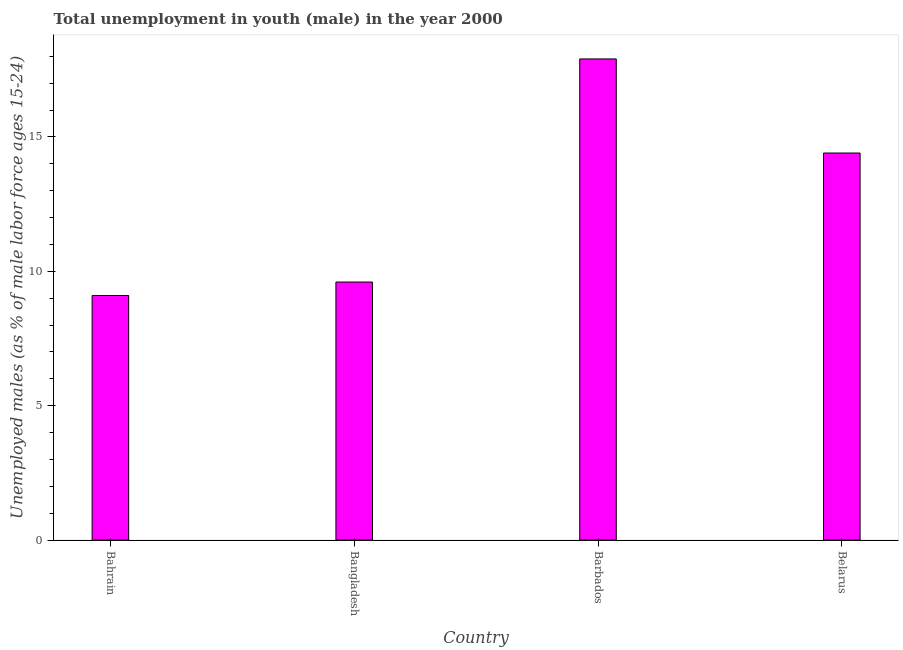What is the title of the graph?
Ensure brevity in your answer.  Total unemployment in youth (male) in the year 2000. What is the label or title of the X-axis?
Offer a terse response. Country. What is the label or title of the Y-axis?
Give a very brief answer. Unemployed males (as % of male labor force ages 15-24). What is the unemployed male youth population in Belarus?
Your answer should be very brief. 14.4. Across all countries, what is the maximum unemployed male youth population?
Provide a short and direct response. 17.9. Across all countries, what is the minimum unemployed male youth population?
Ensure brevity in your answer.  9.1. In which country was the unemployed male youth population maximum?
Make the answer very short. Barbados. In which country was the unemployed male youth population minimum?
Your answer should be compact. Bahrain. What is the sum of the unemployed male youth population?
Provide a succinct answer. 51. What is the average unemployed male youth population per country?
Your answer should be compact. 12.75. What is the median unemployed male youth population?
Make the answer very short. 12. In how many countries, is the unemployed male youth population greater than 9 %?
Provide a succinct answer. 4. What is the ratio of the unemployed male youth population in Bangladesh to that in Barbados?
Give a very brief answer. 0.54. What is the difference between the highest and the second highest unemployed male youth population?
Provide a short and direct response. 3.5. What is the difference between the highest and the lowest unemployed male youth population?
Your answer should be compact. 8.8. Are all the bars in the graph horizontal?
Your response must be concise. No. Are the values on the major ticks of Y-axis written in scientific E-notation?
Your response must be concise. No. What is the Unemployed males (as % of male labor force ages 15-24) of Bahrain?
Provide a succinct answer. 9.1. What is the Unemployed males (as % of male labor force ages 15-24) in Bangladesh?
Offer a terse response. 9.6. What is the Unemployed males (as % of male labor force ages 15-24) of Barbados?
Your answer should be compact. 17.9. What is the Unemployed males (as % of male labor force ages 15-24) of Belarus?
Offer a very short reply. 14.4. What is the difference between the Unemployed males (as % of male labor force ages 15-24) in Bangladesh and Barbados?
Your answer should be compact. -8.3. What is the difference between the Unemployed males (as % of male labor force ages 15-24) in Bangladesh and Belarus?
Ensure brevity in your answer.  -4.8. What is the ratio of the Unemployed males (as % of male labor force ages 15-24) in Bahrain to that in Bangladesh?
Ensure brevity in your answer.  0.95. What is the ratio of the Unemployed males (as % of male labor force ages 15-24) in Bahrain to that in Barbados?
Your answer should be very brief. 0.51. What is the ratio of the Unemployed males (as % of male labor force ages 15-24) in Bahrain to that in Belarus?
Keep it short and to the point. 0.63. What is the ratio of the Unemployed males (as % of male labor force ages 15-24) in Bangladesh to that in Barbados?
Your answer should be compact. 0.54. What is the ratio of the Unemployed males (as % of male labor force ages 15-24) in Bangladesh to that in Belarus?
Keep it short and to the point. 0.67. What is the ratio of the Unemployed males (as % of male labor force ages 15-24) in Barbados to that in Belarus?
Give a very brief answer. 1.24. 